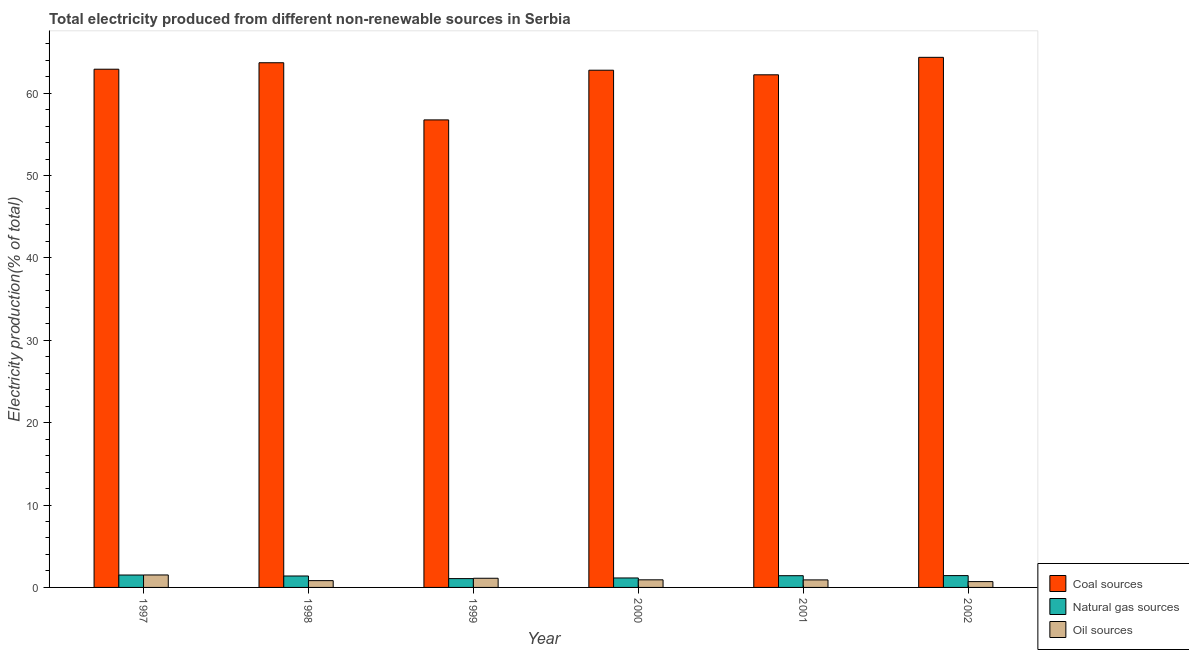How many different coloured bars are there?
Ensure brevity in your answer.  3. How many bars are there on the 3rd tick from the left?
Offer a very short reply. 3. How many bars are there on the 2nd tick from the right?
Give a very brief answer. 3. What is the label of the 6th group of bars from the left?
Give a very brief answer. 2002. In how many cases, is the number of bars for a given year not equal to the number of legend labels?
Ensure brevity in your answer.  0. What is the percentage of electricity produced by oil sources in 2000?
Offer a very short reply. 0.92. Across all years, what is the maximum percentage of electricity produced by coal?
Your answer should be very brief. 64.34. Across all years, what is the minimum percentage of electricity produced by oil sources?
Your response must be concise. 0.71. In which year was the percentage of electricity produced by natural gas maximum?
Provide a succinct answer. 1997. What is the total percentage of electricity produced by natural gas in the graph?
Your answer should be compact. 7.97. What is the difference between the percentage of electricity produced by oil sources in 1997 and that in 2001?
Offer a terse response. 0.6. What is the difference between the percentage of electricity produced by natural gas in 1999 and the percentage of electricity produced by oil sources in 1997?
Your answer should be compact. -0.43. What is the average percentage of electricity produced by coal per year?
Keep it short and to the point. 62.11. In how many years, is the percentage of electricity produced by natural gas greater than 28 %?
Offer a very short reply. 0. What is the ratio of the percentage of electricity produced by coal in 1998 to that in 2000?
Your answer should be compact. 1.01. Is the percentage of electricity produced by coal in 2000 less than that in 2001?
Offer a terse response. No. What is the difference between the highest and the second highest percentage of electricity produced by natural gas?
Offer a terse response. 0.07. What is the difference between the highest and the lowest percentage of electricity produced by coal?
Offer a terse response. 7.59. In how many years, is the percentage of electricity produced by natural gas greater than the average percentage of electricity produced by natural gas taken over all years?
Offer a very short reply. 4. Is the sum of the percentage of electricity produced by oil sources in 1999 and 2000 greater than the maximum percentage of electricity produced by natural gas across all years?
Your answer should be very brief. Yes. What does the 1st bar from the left in 1997 represents?
Offer a very short reply. Coal sources. What does the 3rd bar from the right in 1998 represents?
Provide a succinct answer. Coal sources. Are the values on the major ticks of Y-axis written in scientific E-notation?
Give a very brief answer. No. Does the graph contain any zero values?
Your response must be concise. No. How are the legend labels stacked?
Your answer should be compact. Vertical. What is the title of the graph?
Offer a terse response. Total electricity produced from different non-renewable sources in Serbia. What is the label or title of the X-axis?
Keep it short and to the point. Year. What is the label or title of the Y-axis?
Your answer should be very brief. Electricity production(% of total). What is the Electricity production(% of total) of Coal sources in 1997?
Keep it short and to the point. 62.9. What is the Electricity production(% of total) of Natural gas sources in 1997?
Make the answer very short. 1.51. What is the Electricity production(% of total) in Oil sources in 1997?
Offer a very short reply. 1.51. What is the Electricity production(% of total) of Coal sources in 1998?
Your response must be concise. 63.69. What is the Electricity production(% of total) of Natural gas sources in 1998?
Provide a short and direct response. 1.39. What is the Electricity production(% of total) of Oil sources in 1998?
Your answer should be compact. 0.83. What is the Electricity production(% of total) of Coal sources in 1999?
Your response must be concise. 56.75. What is the Electricity production(% of total) of Natural gas sources in 1999?
Provide a short and direct response. 1.07. What is the Electricity production(% of total) of Oil sources in 1999?
Your response must be concise. 1.11. What is the Electricity production(% of total) in Coal sources in 2000?
Ensure brevity in your answer.  62.78. What is the Electricity production(% of total) in Natural gas sources in 2000?
Your answer should be compact. 1.15. What is the Electricity production(% of total) of Oil sources in 2000?
Your answer should be compact. 0.92. What is the Electricity production(% of total) in Coal sources in 2001?
Offer a terse response. 62.22. What is the Electricity production(% of total) of Natural gas sources in 2001?
Your response must be concise. 1.42. What is the Electricity production(% of total) of Oil sources in 2001?
Ensure brevity in your answer.  0.91. What is the Electricity production(% of total) in Coal sources in 2002?
Provide a succinct answer. 64.34. What is the Electricity production(% of total) of Natural gas sources in 2002?
Provide a short and direct response. 1.43. What is the Electricity production(% of total) in Oil sources in 2002?
Your answer should be very brief. 0.71. Across all years, what is the maximum Electricity production(% of total) in Coal sources?
Offer a terse response. 64.34. Across all years, what is the maximum Electricity production(% of total) in Natural gas sources?
Your answer should be very brief. 1.51. Across all years, what is the maximum Electricity production(% of total) of Oil sources?
Provide a succinct answer. 1.51. Across all years, what is the minimum Electricity production(% of total) in Coal sources?
Provide a succinct answer. 56.75. Across all years, what is the minimum Electricity production(% of total) of Natural gas sources?
Your response must be concise. 1.07. Across all years, what is the minimum Electricity production(% of total) in Oil sources?
Your answer should be very brief. 0.71. What is the total Electricity production(% of total) of Coal sources in the graph?
Keep it short and to the point. 372.69. What is the total Electricity production(% of total) in Natural gas sources in the graph?
Your answer should be very brief. 7.97. What is the total Electricity production(% of total) in Oil sources in the graph?
Provide a succinct answer. 6. What is the difference between the Electricity production(% of total) in Coal sources in 1997 and that in 1998?
Provide a short and direct response. -0.79. What is the difference between the Electricity production(% of total) of Natural gas sources in 1997 and that in 1998?
Make the answer very short. 0.12. What is the difference between the Electricity production(% of total) in Oil sources in 1997 and that in 1998?
Provide a succinct answer. 0.69. What is the difference between the Electricity production(% of total) in Coal sources in 1997 and that in 1999?
Provide a short and direct response. 6.15. What is the difference between the Electricity production(% of total) in Natural gas sources in 1997 and that in 1999?
Give a very brief answer. 0.43. What is the difference between the Electricity production(% of total) in Oil sources in 1997 and that in 1999?
Provide a short and direct response. 0.4. What is the difference between the Electricity production(% of total) in Coal sources in 1997 and that in 2000?
Offer a very short reply. 0.12. What is the difference between the Electricity production(% of total) of Natural gas sources in 1997 and that in 2000?
Keep it short and to the point. 0.36. What is the difference between the Electricity production(% of total) of Oil sources in 1997 and that in 2000?
Offer a very short reply. 0.59. What is the difference between the Electricity production(% of total) of Coal sources in 1997 and that in 2001?
Make the answer very short. 0.68. What is the difference between the Electricity production(% of total) of Natural gas sources in 1997 and that in 2001?
Make the answer very short. 0.08. What is the difference between the Electricity production(% of total) of Oil sources in 1997 and that in 2001?
Ensure brevity in your answer.  0.6. What is the difference between the Electricity production(% of total) of Coal sources in 1997 and that in 2002?
Give a very brief answer. -1.44. What is the difference between the Electricity production(% of total) of Natural gas sources in 1997 and that in 2002?
Provide a succinct answer. 0.07. What is the difference between the Electricity production(% of total) in Oil sources in 1997 and that in 2002?
Your response must be concise. 0.81. What is the difference between the Electricity production(% of total) in Coal sources in 1998 and that in 1999?
Your answer should be compact. 6.94. What is the difference between the Electricity production(% of total) in Natural gas sources in 1998 and that in 1999?
Your answer should be very brief. 0.32. What is the difference between the Electricity production(% of total) in Oil sources in 1998 and that in 1999?
Provide a succinct answer. -0.29. What is the difference between the Electricity production(% of total) of Coal sources in 1998 and that in 2000?
Offer a terse response. 0.91. What is the difference between the Electricity production(% of total) of Natural gas sources in 1998 and that in 2000?
Your answer should be compact. 0.24. What is the difference between the Electricity production(% of total) of Oil sources in 1998 and that in 2000?
Ensure brevity in your answer.  -0.1. What is the difference between the Electricity production(% of total) in Coal sources in 1998 and that in 2001?
Your response must be concise. 1.46. What is the difference between the Electricity production(% of total) of Natural gas sources in 1998 and that in 2001?
Provide a short and direct response. -0.03. What is the difference between the Electricity production(% of total) in Oil sources in 1998 and that in 2001?
Your answer should be very brief. -0.09. What is the difference between the Electricity production(% of total) of Coal sources in 1998 and that in 2002?
Your response must be concise. -0.66. What is the difference between the Electricity production(% of total) in Natural gas sources in 1998 and that in 2002?
Provide a short and direct response. -0.05. What is the difference between the Electricity production(% of total) of Oil sources in 1998 and that in 2002?
Keep it short and to the point. 0.12. What is the difference between the Electricity production(% of total) in Coal sources in 1999 and that in 2000?
Provide a short and direct response. -6.03. What is the difference between the Electricity production(% of total) of Natural gas sources in 1999 and that in 2000?
Provide a succinct answer. -0.08. What is the difference between the Electricity production(% of total) in Oil sources in 1999 and that in 2000?
Give a very brief answer. 0.19. What is the difference between the Electricity production(% of total) in Coal sources in 1999 and that in 2001?
Your response must be concise. -5.47. What is the difference between the Electricity production(% of total) of Natural gas sources in 1999 and that in 2001?
Your answer should be very brief. -0.35. What is the difference between the Electricity production(% of total) in Oil sources in 1999 and that in 2001?
Give a very brief answer. 0.2. What is the difference between the Electricity production(% of total) of Coal sources in 1999 and that in 2002?
Your response must be concise. -7.59. What is the difference between the Electricity production(% of total) in Natural gas sources in 1999 and that in 2002?
Make the answer very short. -0.36. What is the difference between the Electricity production(% of total) in Oil sources in 1999 and that in 2002?
Offer a terse response. 0.41. What is the difference between the Electricity production(% of total) of Coal sources in 2000 and that in 2001?
Offer a very short reply. 0.56. What is the difference between the Electricity production(% of total) in Natural gas sources in 2000 and that in 2001?
Your answer should be very brief. -0.28. What is the difference between the Electricity production(% of total) of Oil sources in 2000 and that in 2001?
Provide a succinct answer. 0.01. What is the difference between the Electricity production(% of total) in Coal sources in 2000 and that in 2002?
Your answer should be compact. -1.56. What is the difference between the Electricity production(% of total) in Natural gas sources in 2000 and that in 2002?
Your answer should be very brief. -0.29. What is the difference between the Electricity production(% of total) of Oil sources in 2000 and that in 2002?
Give a very brief answer. 0.22. What is the difference between the Electricity production(% of total) of Coal sources in 2001 and that in 2002?
Your answer should be compact. -2.12. What is the difference between the Electricity production(% of total) of Natural gas sources in 2001 and that in 2002?
Keep it short and to the point. -0.01. What is the difference between the Electricity production(% of total) of Oil sources in 2001 and that in 2002?
Your answer should be compact. 0.21. What is the difference between the Electricity production(% of total) in Coal sources in 1997 and the Electricity production(% of total) in Natural gas sources in 1998?
Your answer should be compact. 61.51. What is the difference between the Electricity production(% of total) of Coal sources in 1997 and the Electricity production(% of total) of Oil sources in 1998?
Your answer should be very brief. 62.08. What is the difference between the Electricity production(% of total) of Natural gas sources in 1997 and the Electricity production(% of total) of Oil sources in 1998?
Provide a succinct answer. 0.68. What is the difference between the Electricity production(% of total) in Coal sources in 1997 and the Electricity production(% of total) in Natural gas sources in 1999?
Offer a very short reply. 61.83. What is the difference between the Electricity production(% of total) of Coal sources in 1997 and the Electricity production(% of total) of Oil sources in 1999?
Your answer should be compact. 61.79. What is the difference between the Electricity production(% of total) of Natural gas sources in 1997 and the Electricity production(% of total) of Oil sources in 1999?
Make the answer very short. 0.39. What is the difference between the Electricity production(% of total) in Coal sources in 1997 and the Electricity production(% of total) in Natural gas sources in 2000?
Your response must be concise. 61.75. What is the difference between the Electricity production(% of total) in Coal sources in 1997 and the Electricity production(% of total) in Oil sources in 2000?
Your answer should be very brief. 61.98. What is the difference between the Electricity production(% of total) in Natural gas sources in 1997 and the Electricity production(% of total) in Oil sources in 2000?
Provide a short and direct response. 0.58. What is the difference between the Electricity production(% of total) of Coal sources in 1997 and the Electricity production(% of total) of Natural gas sources in 2001?
Make the answer very short. 61.48. What is the difference between the Electricity production(% of total) in Coal sources in 1997 and the Electricity production(% of total) in Oil sources in 2001?
Your answer should be very brief. 61.99. What is the difference between the Electricity production(% of total) in Natural gas sources in 1997 and the Electricity production(% of total) in Oil sources in 2001?
Your response must be concise. 0.59. What is the difference between the Electricity production(% of total) of Coal sources in 1997 and the Electricity production(% of total) of Natural gas sources in 2002?
Your answer should be compact. 61.47. What is the difference between the Electricity production(% of total) of Coal sources in 1997 and the Electricity production(% of total) of Oil sources in 2002?
Your answer should be very brief. 62.19. What is the difference between the Electricity production(% of total) in Natural gas sources in 1997 and the Electricity production(% of total) in Oil sources in 2002?
Provide a succinct answer. 0.8. What is the difference between the Electricity production(% of total) of Coal sources in 1998 and the Electricity production(% of total) of Natural gas sources in 1999?
Give a very brief answer. 62.62. What is the difference between the Electricity production(% of total) of Coal sources in 1998 and the Electricity production(% of total) of Oil sources in 1999?
Give a very brief answer. 62.57. What is the difference between the Electricity production(% of total) of Natural gas sources in 1998 and the Electricity production(% of total) of Oil sources in 1999?
Keep it short and to the point. 0.28. What is the difference between the Electricity production(% of total) in Coal sources in 1998 and the Electricity production(% of total) in Natural gas sources in 2000?
Give a very brief answer. 62.54. What is the difference between the Electricity production(% of total) of Coal sources in 1998 and the Electricity production(% of total) of Oil sources in 2000?
Make the answer very short. 62.76. What is the difference between the Electricity production(% of total) of Natural gas sources in 1998 and the Electricity production(% of total) of Oil sources in 2000?
Provide a succinct answer. 0.47. What is the difference between the Electricity production(% of total) in Coal sources in 1998 and the Electricity production(% of total) in Natural gas sources in 2001?
Your response must be concise. 62.26. What is the difference between the Electricity production(% of total) in Coal sources in 1998 and the Electricity production(% of total) in Oil sources in 2001?
Keep it short and to the point. 62.77. What is the difference between the Electricity production(% of total) in Natural gas sources in 1998 and the Electricity production(% of total) in Oil sources in 2001?
Give a very brief answer. 0.47. What is the difference between the Electricity production(% of total) of Coal sources in 1998 and the Electricity production(% of total) of Natural gas sources in 2002?
Your answer should be very brief. 62.25. What is the difference between the Electricity production(% of total) of Coal sources in 1998 and the Electricity production(% of total) of Oil sources in 2002?
Ensure brevity in your answer.  62.98. What is the difference between the Electricity production(% of total) of Natural gas sources in 1998 and the Electricity production(% of total) of Oil sources in 2002?
Your answer should be compact. 0.68. What is the difference between the Electricity production(% of total) in Coal sources in 1999 and the Electricity production(% of total) in Natural gas sources in 2000?
Make the answer very short. 55.6. What is the difference between the Electricity production(% of total) of Coal sources in 1999 and the Electricity production(% of total) of Oil sources in 2000?
Make the answer very short. 55.83. What is the difference between the Electricity production(% of total) of Natural gas sources in 1999 and the Electricity production(% of total) of Oil sources in 2000?
Your response must be concise. 0.15. What is the difference between the Electricity production(% of total) of Coal sources in 1999 and the Electricity production(% of total) of Natural gas sources in 2001?
Your response must be concise. 55.33. What is the difference between the Electricity production(% of total) in Coal sources in 1999 and the Electricity production(% of total) in Oil sources in 2001?
Offer a very short reply. 55.84. What is the difference between the Electricity production(% of total) in Natural gas sources in 1999 and the Electricity production(% of total) in Oil sources in 2001?
Offer a terse response. 0.16. What is the difference between the Electricity production(% of total) in Coal sources in 1999 and the Electricity production(% of total) in Natural gas sources in 2002?
Your answer should be very brief. 55.31. What is the difference between the Electricity production(% of total) of Coal sources in 1999 and the Electricity production(% of total) of Oil sources in 2002?
Keep it short and to the point. 56.04. What is the difference between the Electricity production(% of total) of Natural gas sources in 1999 and the Electricity production(% of total) of Oil sources in 2002?
Provide a short and direct response. 0.36. What is the difference between the Electricity production(% of total) of Coal sources in 2000 and the Electricity production(% of total) of Natural gas sources in 2001?
Give a very brief answer. 61.36. What is the difference between the Electricity production(% of total) in Coal sources in 2000 and the Electricity production(% of total) in Oil sources in 2001?
Make the answer very short. 61.87. What is the difference between the Electricity production(% of total) of Natural gas sources in 2000 and the Electricity production(% of total) of Oil sources in 2001?
Your response must be concise. 0.23. What is the difference between the Electricity production(% of total) of Coal sources in 2000 and the Electricity production(% of total) of Natural gas sources in 2002?
Ensure brevity in your answer.  61.34. What is the difference between the Electricity production(% of total) of Coal sources in 2000 and the Electricity production(% of total) of Oil sources in 2002?
Your answer should be very brief. 62.07. What is the difference between the Electricity production(% of total) in Natural gas sources in 2000 and the Electricity production(% of total) in Oil sources in 2002?
Give a very brief answer. 0.44. What is the difference between the Electricity production(% of total) in Coal sources in 2001 and the Electricity production(% of total) in Natural gas sources in 2002?
Offer a terse response. 60.79. What is the difference between the Electricity production(% of total) in Coal sources in 2001 and the Electricity production(% of total) in Oil sources in 2002?
Provide a succinct answer. 61.52. What is the difference between the Electricity production(% of total) in Natural gas sources in 2001 and the Electricity production(% of total) in Oil sources in 2002?
Your response must be concise. 0.72. What is the average Electricity production(% of total) in Coal sources per year?
Make the answer very short. 62.11. What is the average Electricity production(% of total) in Natural gas sources per year?
Provide a short and direct response. 1.33. What is the average Electricity production(% of total) of Oil sources per year?
Ensure brevity in your answer.  1. In the year 1997, what is the difference between the Electricity production(% of total) of Coal sources and Electricity production(% of total) of Natural gas sources?
Provide a short and direct response. 61.4. In the year 1997, what is the difference between the Electricity production(% of total) of Coal sources and Electricity production(% of total) of Oil sources?
Your response must be concise. 61.39. In the year 1997, what is the difference between the Electricity production(% of total) of Natural gas sources and Electricity production(% of total) of Oil sources?
Provide a succinct answer. -0.01. In the year 1998, what is the difference between the Electricity production(% of total) in Coal sources and Electricity production(% of total) in Natural gas sources?
Offer a terse response. 62.3. In the year 1998, what is the difference between the Electricity production(% of total) of Coal sources and Electricity production(% of total) of Oil sources?
Your answer should be very brief. 62.86. In the year 1998, what is the difference between the Electricity production(% of total) of Natural gas sources and Electricity production(% of total) of Oil sources?
Provide a short and direct response. 0.56. In the year 1999, what is the difference between the Electricity production(% of total) of Coal sources and Electricity production(% of total) of Natural gas sources?
Your response must be concise. 55.68. In the year 1999, what is the difference between the Electricity production(% of total) in Coal sources and Electricity production(% of total) in Oil sources?
Provide a succinct answer. 55.64. In the year 1999, what is the difference between the Electricity production(% of total) in Natural gas sources and Electricity production(% of total) in Oil sources?
Offer a very short reply. -0.04. In the year 2000, what is the difference between the Electricity production(% of total) in Coal sources and Electricity production(% of total) in Natural gas sources?
Your response must be concise. 61.63. In the year 2000, what is the difference between the Electricity production(% of total) of Coal sources and Electricity production(% of total) of Oil sources?
Ensure brevity in your answer.  61.86. In the year 2000, what is the difference between the Electricity production(% of total) of Natural gas sources and Electricity production(% of total) of Oil sources?
Offer a very short reply. 0.23. In the year 2001, what is the difference between the Electricity production(% of total) in Coal sources and Electricity production(% of total) in Natural gas sources?
Your response must be concise. 60.8. In the year 2001, what is the difference between the Electricity production(% of total) of Coal sources and Electricity production(% of total) of Oil sources?
Make the answer very short. 61.31. In the year 2001, what is the difference between the Electricity production(% of total) of Natural gas sources and Electricity production(% of total) of Oil sources?
Provide a short and direct response. 0.51. In the year 2002, what is the difference between the Electricity production(% of total) of Coal sources and Electricity production(% of total) of Natural gas sources?
Ensure brevity in your answer.  62.91. In the year 2002, what is the difference between the Electricity production(% of total) in Coal sources and Electricity production(% of total) in Oil sources?
Give a very brief answer. 63.64. In the year 2002, what is the difference between the Electricity production(% of total) of Natural gas sources and Electricity production(% of total) of Oil sources?
Keep it short and to the point. 0.73. What is the ratio of the Electricity production(% of total) of Natural gas sources in 1997 to that in 1998?
Offer a terse response. 1.08. What is the ratio of the Electricity production(% of total) of Oil sources in 1997 to that in 1998?
Give a very brief answer. 1.83. What is the ratio of the Electricity production(% of total) in Coal sources in 1997 to that in 1999?
Offer a terse response. 1.11. What is the ratio of the Electricity production(% of total) of Natural gas sources in 1997 to that in 1999?
Ensure brevity in your answer.  1.41. What is the ratio of the Electricity production(% of total) of Oil sources in 1997 to that in 1999?
Your answer should be compact. 1.36. What is the ratio of the Electricity production(% of total) in Natural gas sources in 1997 to that in 2000?
Provide a succinct answer. 1.31. What is the ratio of the Electricity production(% of total) of Oil sources in 1997 to that in 2000?
Your answer should be very brief. 1.64. What is the ratio of the Electricity production(% of total) in Coal sources in 1997 to that in 2001?
Your answer should be compact. 1.01. What is the ratio of the Electricity production(% of total) of Natural gas sources in 1997 to that in 2001?
Ensure brevity in your answer.  1.06. What is the ratio of the Electricity production(% of total) in Oil sources in 1997 to that in 2001?
Give a very brief answer. 1.66. What is the ratio of the Electricity production(% of total) in Coal sources in 1997 to that in 2002?
Provide a succinct answer. 0.98. What is the ratio of the Electricity production(% of total) of Natural gas sources in 1997 to that in 2002?
Your answer should be very brief. 1.05. What is the ratio of the Electricity production(% of total) of Oil sources in 1997 to that in 2002?
Provide a succinct answer. 2.14. What is the ratio of the Electricity production(% of total) in Coal sources in 1998 to that in 1999?
Make the answer very short. 1.12. What is the ratio of the Electricity production(% of total) in Natural gas sources in 1998 to that in 1999?
Provide a succinct answer. 1.3. What is the ratio of the Electricity production(% of total) in Oil sources in 1998 to that in 1999?
Make the answer very short. 0.74. What is the ratio of the Electricity production(% of total) of Coal sources in 1998 to that in 2000?
Keep it short and to the point. 1.01. What is the ratio of the Electricity production(% of total) of Natural gas sources in 1998 to that in 2000?
Your answer should be compact. 1.21. What is the ratio of the Electricity production(% of total) of Oil sources in 1998 to that in 2000?
Offer a terse response. 0.89. What is the ratio of the Electricity production(% of total) in Coal sources in 1998 to that in 2001?
Your answer should be very brief. 1.02. What is the ratio of the Electricity production(% of total) of Natural gas sources in 1998 to that in 2001?
Keep it short and to the point. 0.98. What is the ratio of the Electricity production(% of total) in Oil sources in 1998 to that in 2001?
Ensure brevity in your answer.  0.9. What is the ratio of the Electricity production(% of total) in Coal sources in 1998 to that in 2002?
Ensure brevity in your answer.  0.99. What is the ratio of the Electricity production(% of total) in Natural gas sources in 1998 to that in 2002?
Make the answer very short. 0.97. What is the ratio of the Electricity production(% of total) of Oil sources in 1998 to that in 2002?
Keep it short and to the point. 1.17. What is the ratio of the Electricity production(% of total) in Coal sources in 1999 to that in 2000?
Your response must be concise. 0.9. What is the ratio of the Electricity production(% of total) in Natural gas sources in 1999 to that in 2000?
Ensure brevity in your answer.  0.93. What is the ratio of the Electricity production(% of total) of Oil sources in 1999 to that in 2000?
Keep it short and to the point. 1.21. What is the ratio of the Electricity production(% of total) of Coal sources in 1999 to that in 2001?
Offer a terse response. 0.91. What is the ratio of the Electricity production(% of total) in Natural gas sources in 1999 to that in 2001?
Offer a terse response. 0.75. What is the ratio of the Electricity production(% of total) of Oil sources in 1999 to that in 2001?
Offer a very short reply. 1.22. What is the ratio of the Electricity production(% of total) in Coal sources in 1999 to that in 2002?
Provide a succinct answer. 0.88. What is the ratio of the Electricity production(% of total) in Natural gas sources in 1999 to that in 2002?
Offer a terse response. 0.75. What is the ratio of the Electricity production(% of total) in Oil sources in 1999 to that in 2002?
Give a very brief answer. 1.57. What is the ratio of the Electricity production(% of total) in Coal sources in 2000 to that in 2001?
Offer a terse response. 1.01. What is the ratio of the Electricity production(% of total) of Natural gas sources in 2000 to that in 2001?
Ensure brevity in your answer.  0.81. What is the ratio of the Electricity production(% of total) in Oil sources in 2000 to that in 2001?
Give a very brief answer. 1.01. What is the ratio of the Electricity production(% of total) of Coal sources in 2000 to that in 2002?
Make the answer very short. 0.98. What is the ratio of the Electricity production(% of total) of Natural gas sources in 2000 to that in 2002?
Offer a very short reply. 0.8. What is the ratio of the Electricity production(% of total) of Oil sources in 2000 to that in 2002?
Provide a short and direct response. 1.3. What is the ratio of the Electricity production(% of total) in Coal sources in 2001 to that in 2002?
Make the answer very short. 0.97. What is the ratio of the Electricity production(% of total) in Oil sources in 2001 to that in 2002?
Give a very brief answer. 1.29. What is the difference between the highest and the second highest Electricity production(% of total) of Coal sources?
Your answer should be compact. 0.66. What is the difference between the highest and the second highest Electricity production(% of total) in Natural gas sources?
Your answer should be compact. 0.07. What is the difference between the highest and the second highest Electricity production(% of total) in Oil sources?
Ensure brevity in your answer.  0.4. What is the difference between the highest and the lowest Electricity production(% of total) in Coal sources?
Your response must be concise. 7.59. What is the difference between the highest and the lowest Electricity production(% of total) of Natural gas sources?
Ensure brevity in your answer.  0.43. What is the difference between the highest and the lowest Electricity production(% of total) of Oil sources?
Your answer should be very brief. 0.81. 